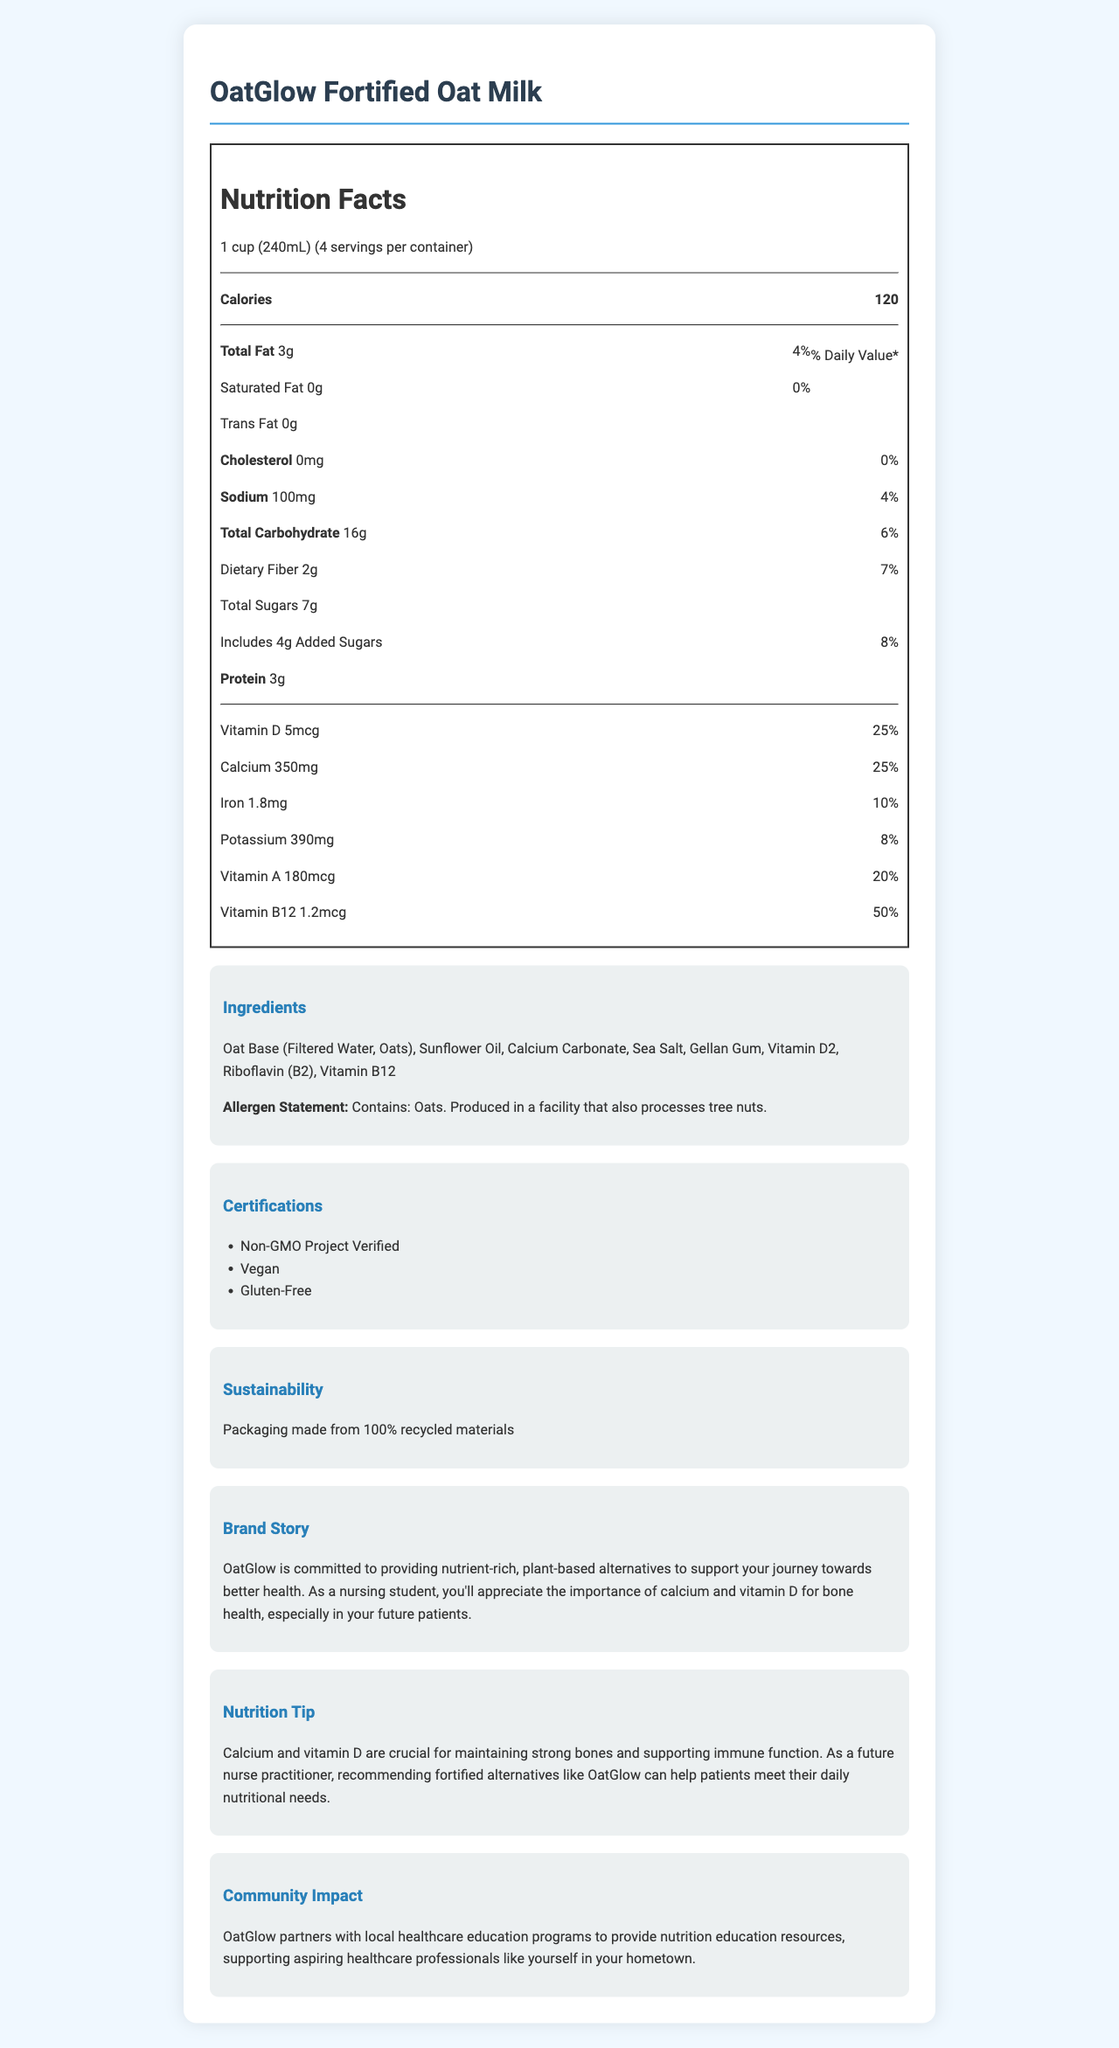what is the serving size for OatGlow Fortified Oat Milk? The document specifies the serving size of the product as 1 cup (240mL).
Answer: 1 cup (240mL) how many calories are there per serving? The nutrition label indicates that there are 120 calories per serving.
Answer: 120 what is the total fat content per serving? The nutrition label lists the total fat content as 3g per serving.
Answer: 3g how much calcium is in one serving, and what percent of the daily value does it represent? The nutrition label shows that one serving contains 350mg of calcium, which is 25% of the daily value.
Answer: 350mg, 25% What vitamins are included in OatGlow Fortified Oat Milk? The document lists vitamins D, A, and B12 in the nutrition facts.
Answer: Vitamin D, Vitamin A, and Vitamin B12 what is the allergen statement provided for OatGlow Fortified Oat Milk? The allergen statement is clearly mentioned in the document.
Answer: Contains: Oats. Produced in a facility that also processes tree nuts. how much protein does one serving contain? The nutrition label indicates that there are 3g of protein per serving.
Answer: 3g What is the main message of the brand story? The brand story emphasizes OatGlow's commitment to health and nutrition through plant-based products.
Answer: OatGlow is committed to providing nutrient-rich, plant-based alternatives to support your journey towards better health. Which certification is NOT mentioned for OatGlow Fortified Oat Milk? A. Non-GMO Project Verified B. Organic C. Vegan D. Gluten-Free The certifications listed do not include "Organic". They are Non-GMO Project Verified, Vegan, and Gluten-Free.
Answer: B Which ingredient is NOT included in OatGlow Fortified Oat Milk? A. Cane Sugar B. Sunflower Oil C. Gellan Gum D. Sea Salt Cane Sugar is not listed among the ingredients. The listed ingredients include Sunflower Oil, Gellan Gum, and Sea Salt.
Answer: A Does OatGlow Fortified Oat Milk contain any added sugars? The nutrition label states that there are 4g of added sugars.
Answer: Yes Is OatGlow Fortified Oat Milk gluten-free? The document mentions that the product is certified Gluten-Free.
Answer: Yes Summarize the document. The summary covers the main points from the nutrition details to certifications, brand ethos, and community engagement.
Answer: The document provides detailed information about OatGlow Fortified Oat Milk, including its nutrition facts, ingredients, certifications, brand story, and community impact. It highlights the product's nutritional benefits and appeal to health-conscious individuals, specifically mentioning its fortification with calcium and vitamin D. The product is suitable for those avoiding GMOs, animal products, and gluten. There's also an emphasis on sustainability and support for healthcare education in local communities. What is the specific type of Vitamin D included in OatGlow Fortified Oat Milk? The document does not detail the specific type of Vitamin D beyond listing it as "Vitamin D2".
Answer: Cannot be determined how much sodium is in one serving, and what percent of the daily value does it represent? The nutrition label shows that one serving contains 100mg of sodium, which is 4% of the daily value.
Answer: 100mg, 4% what is the sustainability statement for OatGlow Fortified Oat Milk? The sustainability info highlights that the packaging is made from 100% recycled materials.
Answer: Packaging made from 100% recycled materials 